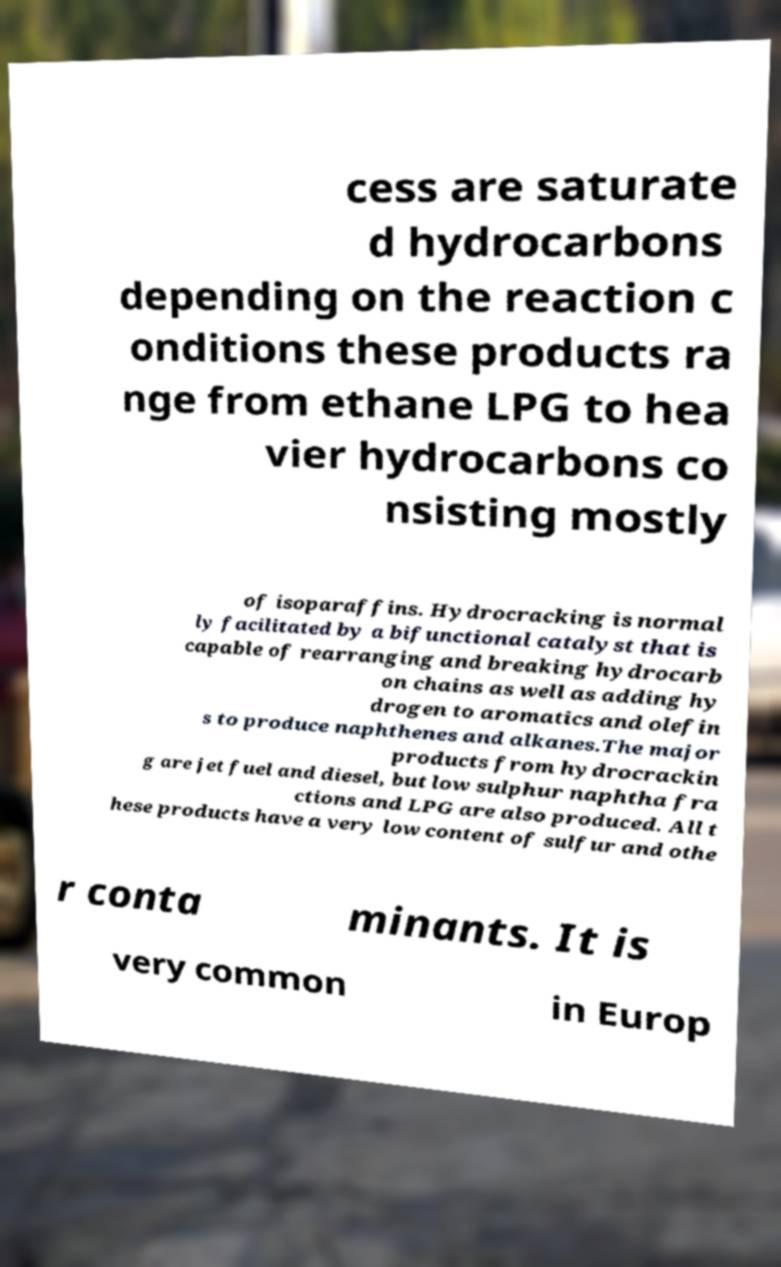There's text embedded in this image that I need extracted. Can you transcribe it verbatim? cess are saturate d hydrocarbons depending on the reaction c onditions these products ra nge from ethane LPG to hea vier hydrocarbons co nsisting mostly of isoparaffins. Hydrocracking is normal ly facilitated by a bifunctional catalyst that is capable of rearranging and breaking hydrocarb on chains as well as adding hy drogen to aromatics and olefin s to produce naphthenes and alkanes.The major products from hydrocrackin g are jet fuel and diesel, but low sulphur naphtha fra ctions and LPG are also produced. All t hese products have a very low content of sulfur and othe r conta minants. It is very common in Europ 